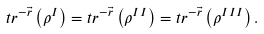<formula> <loc_0><loc_0><loc_500><loc_500>t r ^ { - \vec { r } } \left ( \rho ^ { I } \right ) = t r ^ { - \vec { r } } \left ( \rho ^ { I I } \right ) = t r ^ { - \vec { r } } \left ( \rho ^ { I I I } \right ) .</formula> 